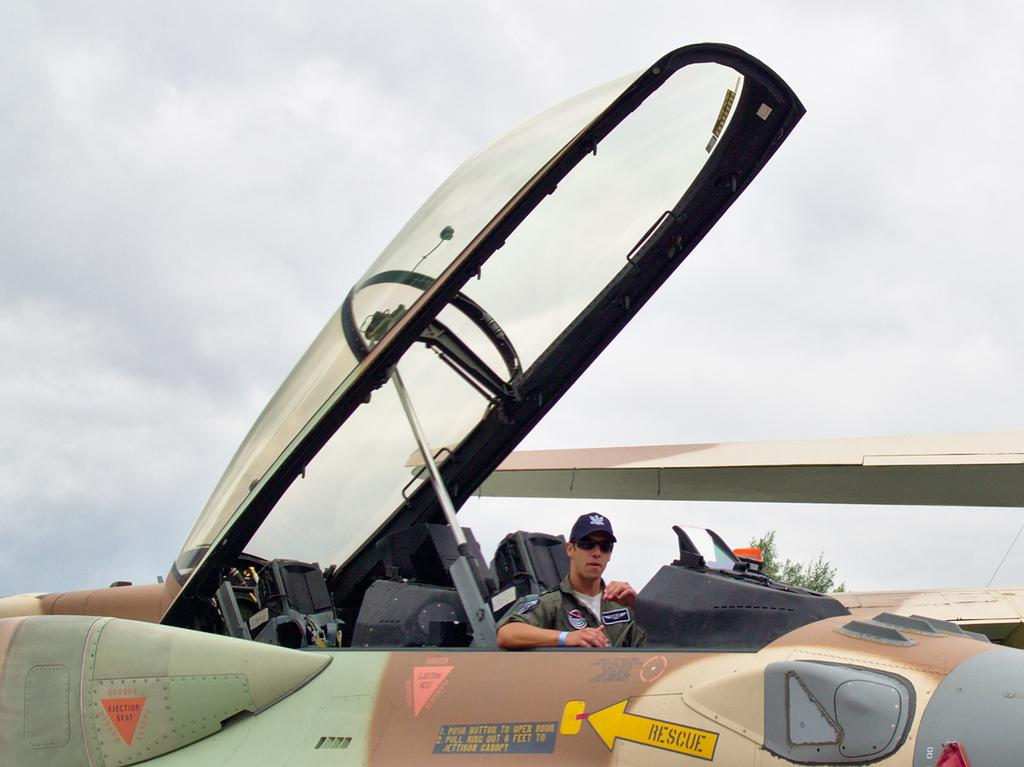What is the main subject of the image? The main subject of the image is airplanes. Are there any other objects or elements in the image besides the airplanes? Yes, there is a tree, a man wearing a cap and goggles, and the sky visible in the background. Can you describe the man's appearance in the image? The man is wearing a cap and goggles. What can be seen in the sky in the image? The sky is visible in the background of the image, and clouds are present. What type of drink is the insect holding in the image? There is no insect present in the image, and therefore no such activity can be observed. 